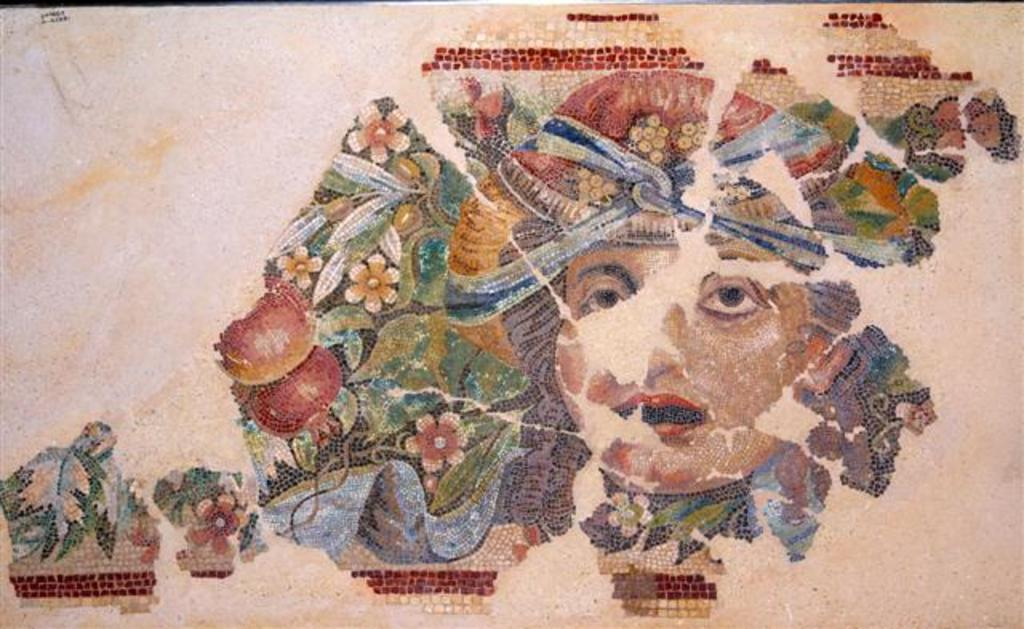What is depicted in the image? There is a painting of a person in the image. What is the medium of the painting? The painting is on a paper. How many goldfish are swimming in the painting? There are no goldfish present in the painting or the image. 